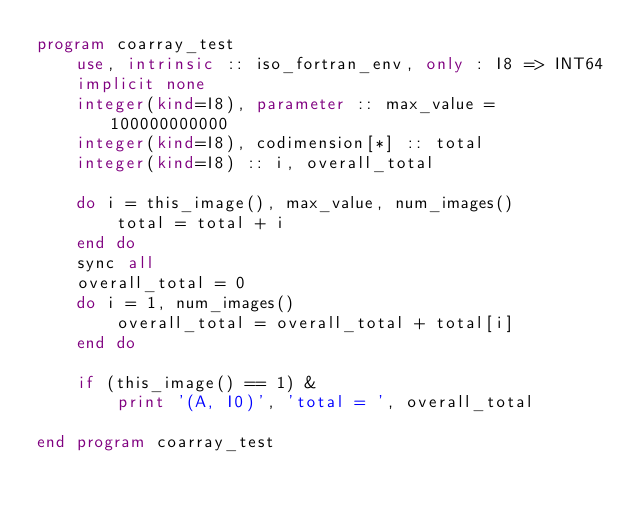<code> <loc_0><loc_0><loc_500><loc_500><_FORTRAN_>program coarray_test
    use, intrinsic :: iso_fortran_env, only : I8 => INT64
    implicit none
    integer(kind=I8), parameter :: max_value = 100000000000
    integer(kind=I8), codimension[*] :: total
    integer(kind=I8) :: i, overall_total

    do i = this_image(), max_value, num_images()
        total = total + i
    end do
    sync all
    overall_total = 0
    do i = 1, num_images()
        overall_total = overall_total + total[i]
    end do

    if (this_image() == 1) &
        print '(A, I0)', 'total = ', overall_total

end program coarray_test
</code> 